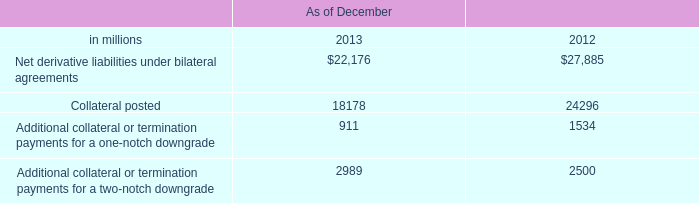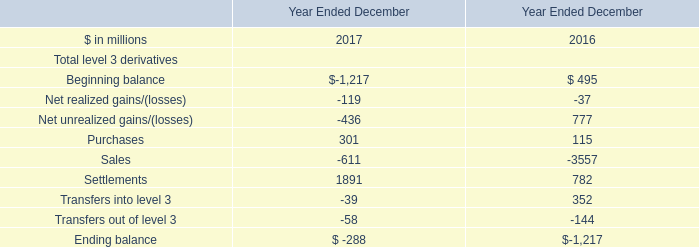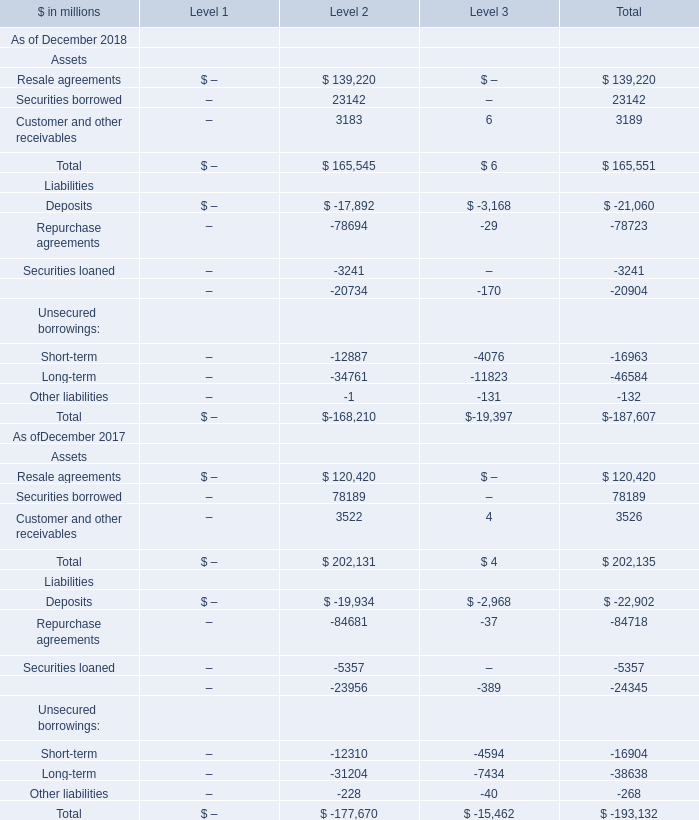What do all Assets sum up in 2018 for Level 2, excluding Resale agreements and Securities borrowed? (in million) 
Answer: 3183. 